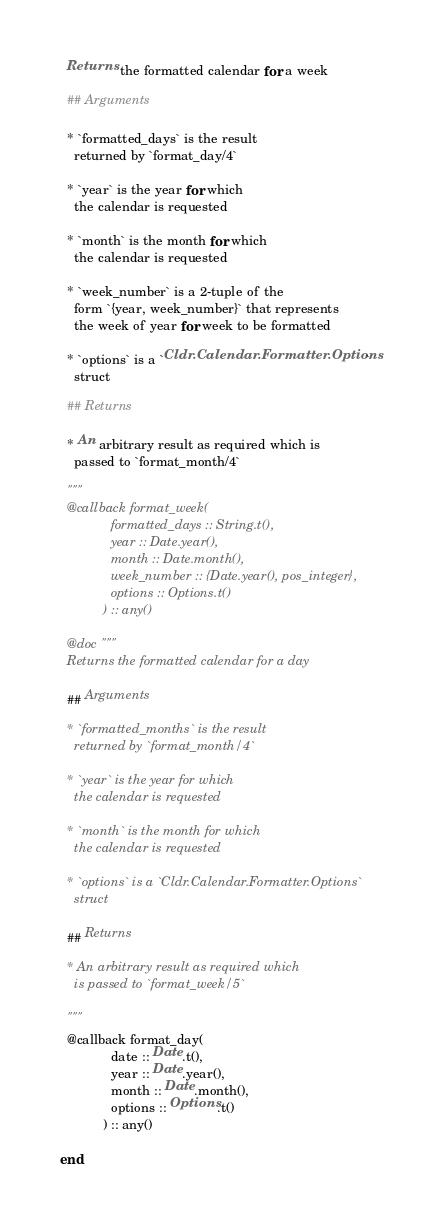Convert code to text. <code><loc_0><loc_0><loc_500><loc_500><_Elixir_>  Returns the formatted calendar for a week

  ## Arguments

  * `formatted_days` is the result
    returned by `format_day/4`

  * `year` is the year for which
    the calendar is requested

  * `month` is the month for which
    the calendar is requested

  * `week_number` is a 2-tuple of the
    form `{year, week_number}` that represents
    the week of year for week to be formatted

  * `options` is a `Cldr.Calendar.Formatter.Options`
    struct

  ## Returns

  * An arbitrary result as required which is
    passed to `format_month/4`

  """
  @callback format_week(
              formatted_days :: String.t(),
              year :: Date.year(),
              month :: Date.month(),
              week_number :: {Date.year(), pos_integer},
              options :: Options.t()
            ) :: any()

  @doc """
  Returns the formatted calendar for a day

  ## Arguments

  * `formatted_months` is the result
    returned by `format_month/4`

  * `year` is the year for which
    the calendar is requested

  * `month` is the month for which
    the calendar is requested

  * `options` is a `Cldr.Calendar.Formatter.Options`
    struct

  ## Returns

  * An arbitrary result as required which
    is passed to `format_week/5`

  """
  @callback format_day(
              date :: Date.t(),
              year :: Date.year(),
              month :: Date.month(),
              options :: Options.t()
            ) :: any()

end
</code> 